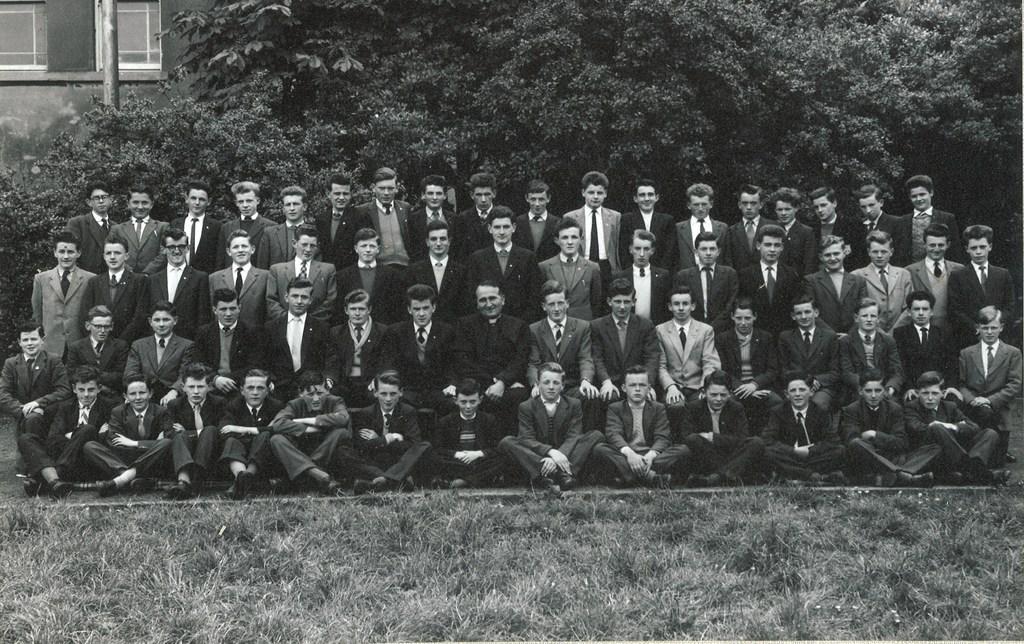How would you summarize this image in a sentence or two? This is a black and white image. In this image we can see many people. On the ground there is grass. In the background there are trees. And there is a building. Also we can see a pole. 